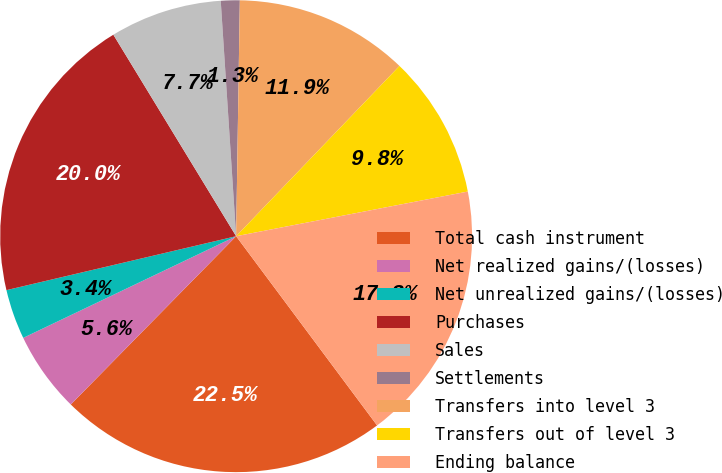Convert chart to OTSL. <chart><loc_0><loc_0><loc_500><loc_500><pie_chart><fcel>Total cash instrument<fcel>Net realized gains/(losses)<fcel>Net unrealized gains/(losses)<fcel>Purchases<fcel>Sales<fcel>Settlements<fcel>Transfers into level 3<fcel>Transfers out of level 3<fcel>Ending balance<nl><fcel>22.55%<fcel>5.55%<fcel>3.42%<fcel>19.96%<fcel>7.67%<fcel>1.29%<fcel>11.92%<fcel>9.8%<fcel>17.84%<nl></chart> 